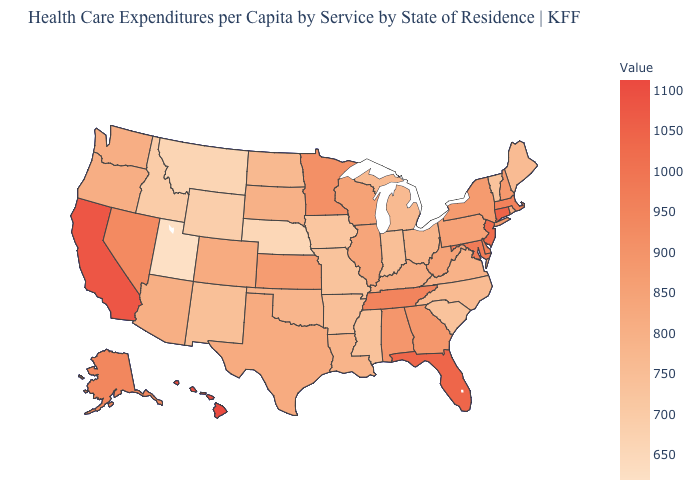Among the states that border New Jersey , does Pennsylvania have the highest value?
Give a very brief answer. No. Does Hawaii have the highest value in the USA?
Concise answer only. Yes. Among the states that border Idaho , does Nevada have the highest value?
Give a very brief answer. Yes. Which states have the highest value in the USA?
Give a very brief answer. Hawaii. Does Ohio have a lower value than South Carolina?
Write a very short answer. No. 